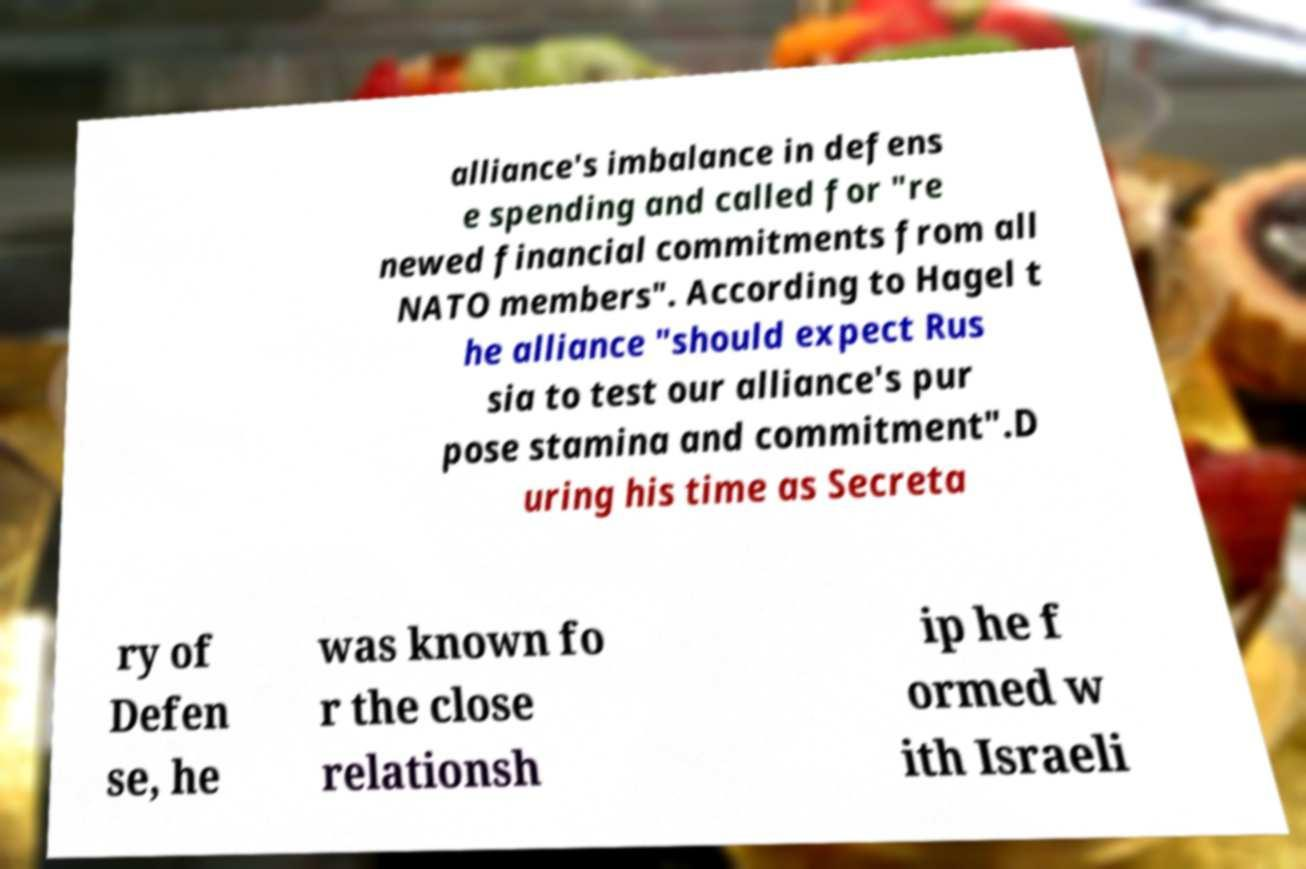For documentation purposes, I need the text within this image transcribed. Could you provide that? alliance's imbalance in defens e spending and called for "re newed financial commitments from all NATO members". According to Hagel t he alliance "should expect Rus sia to test our alliance's pur pose stamina and commitment".D uring his time as Secreta ry of Defen se, he was known fo r the close relationsh ip he f ormed w ith Israeli 